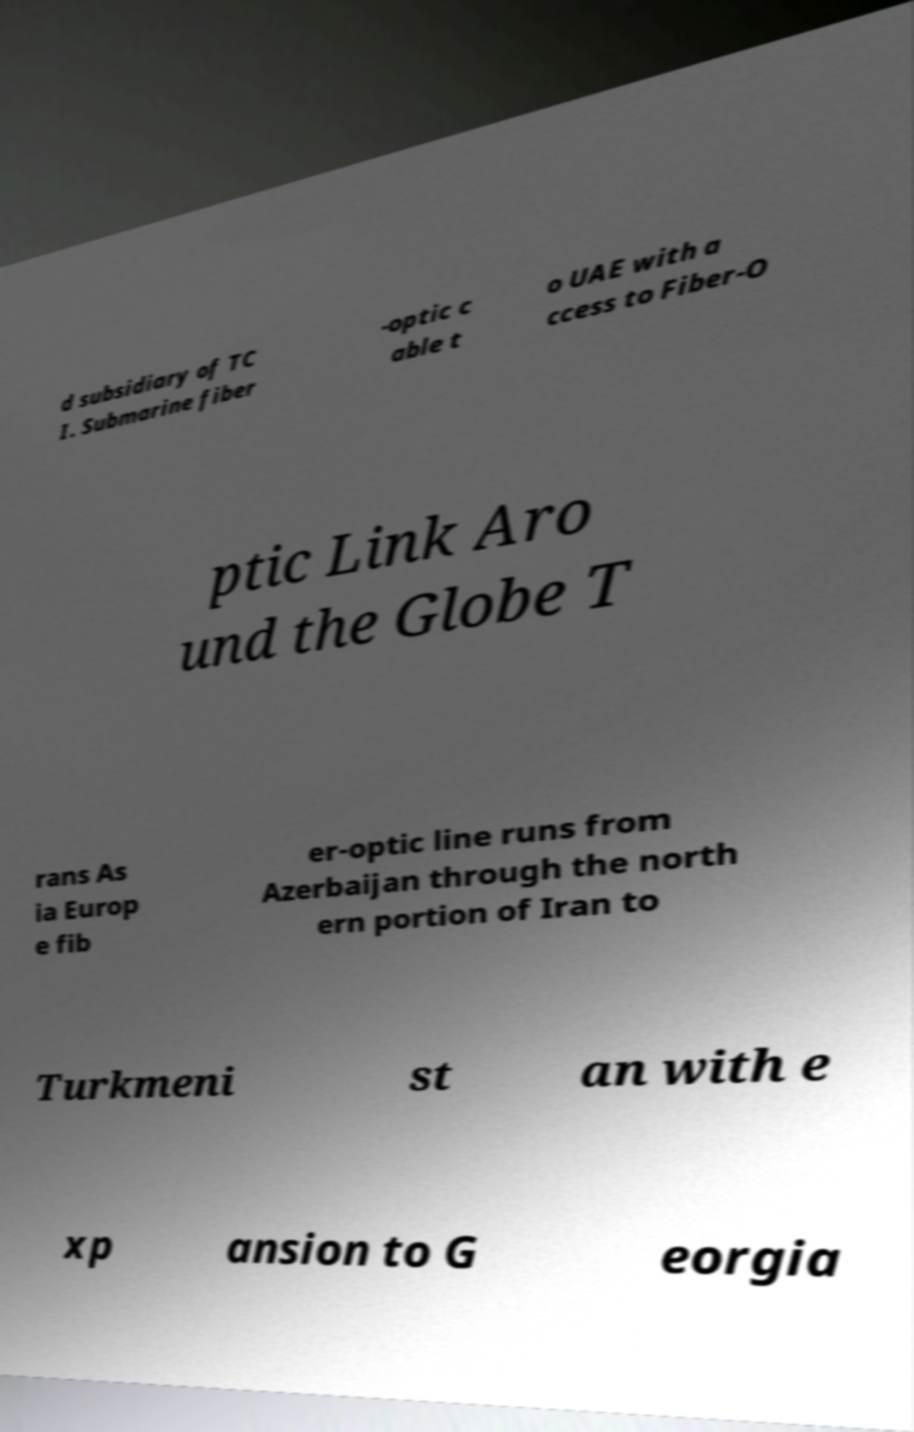There's text embedded in this image that I need extracted. Can you transcribe it verbatim? d subsidiary of TC I. Submarine fiber -optic c able t o UAE with a ccess to Fiber-O ptic Link Aro und the Globe T rans As ia Europ e fib er-optic line runs from Azerbaijan through the north ern portion of Iran to Turkmeni st an with e xp ansion to G eorgia 